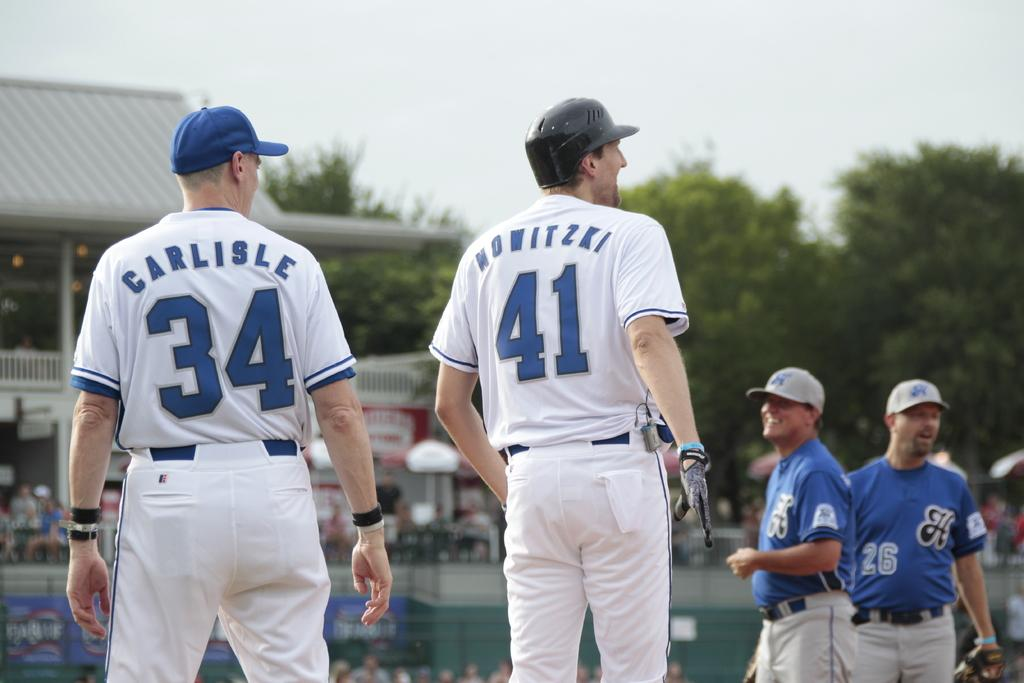<image>
Write a terse but informative summary of the picture. a couple players with one that has the number 41 on 